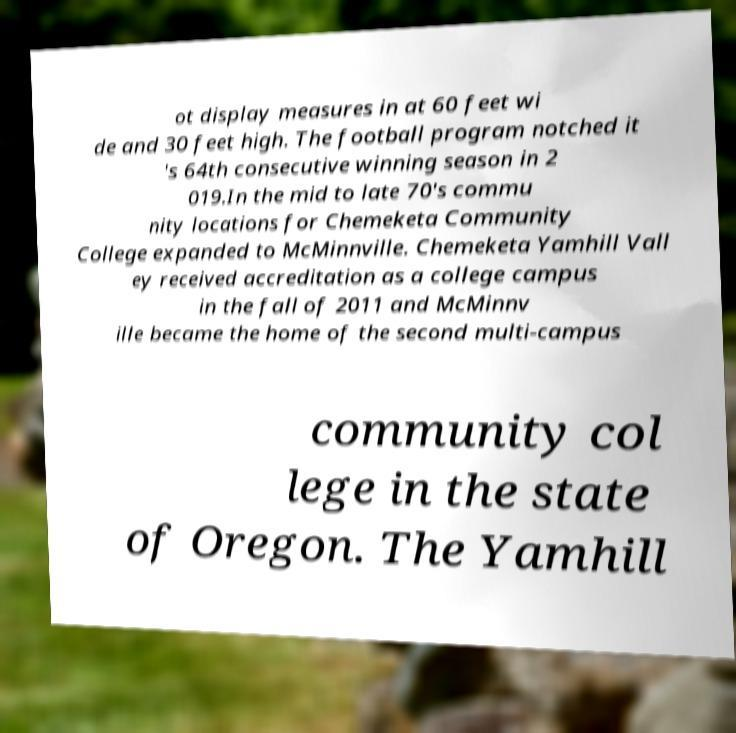What messages or text are displayed in this image? I need them in a readable, typed format. ot display measures in at 60 feet wi de and 30 feet high. The football program notched it 's 64th consecutive winning season in 2 019.In the mid to late 70's commu nity locations for Chemeketa Community College expanded to McMinnville. Chemeketa Yamhill Vall ey received accreditation as a college campus in the fall of 2011 and McMinnv ille became the home of the second multi-campus community col lege in the state of Oregon. The Yamhill 